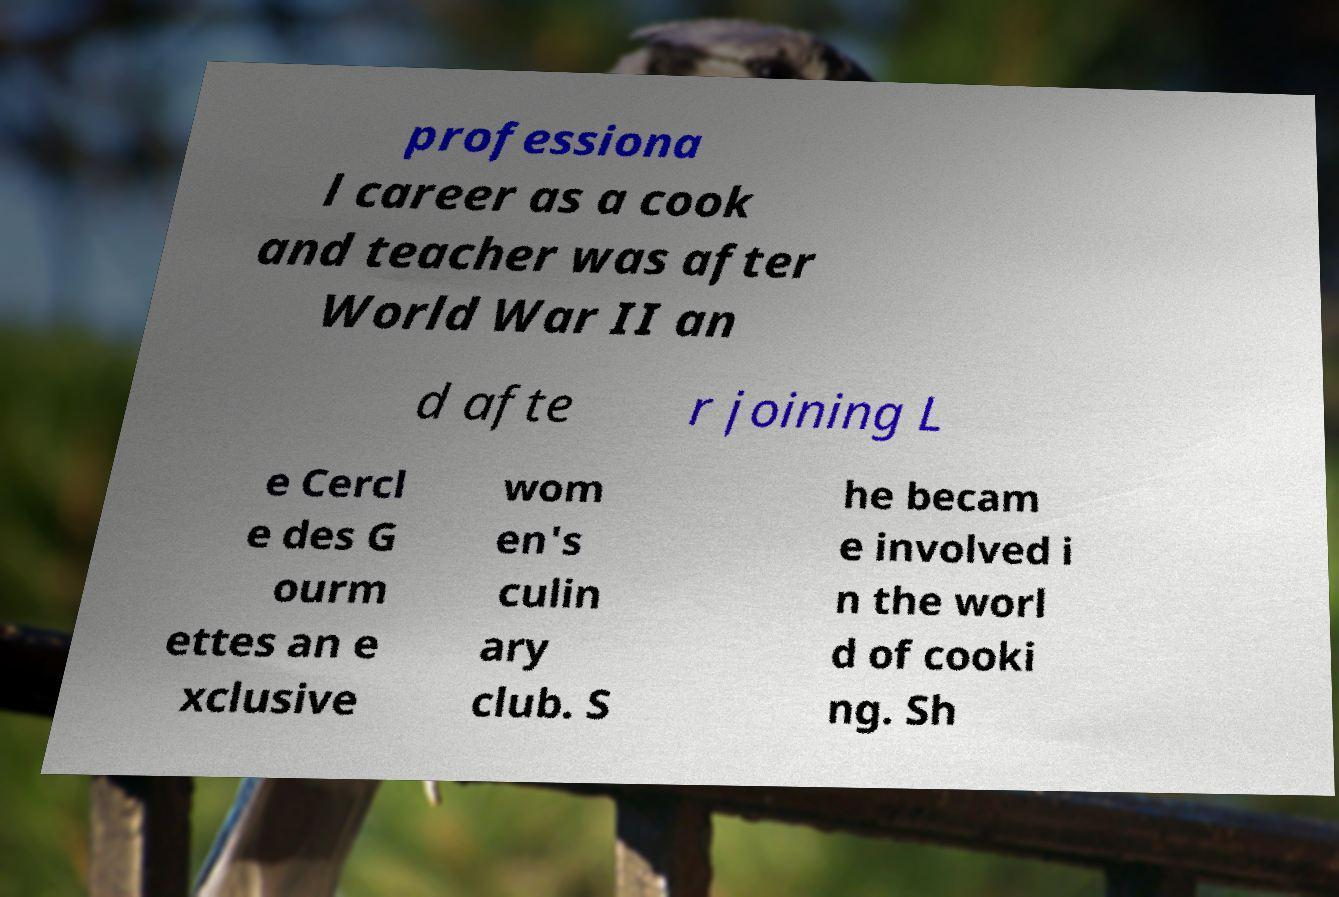Please identify and transcribe the text found in this image. professiona l career as a cook and teacher was after World War II an d afte r joining L e Cercl e des G ourm ettes an e xclusive wom en's culin ary club. S he becam e involved i n the worl d of cooki ng. Sh 